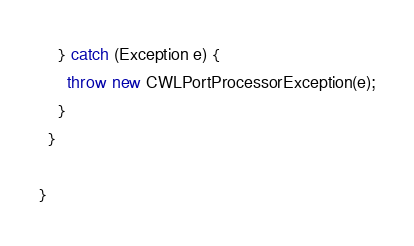<code> <loc_0><loc_0><loc_500><loc_500><_Java_>    } catch (Exception e) {
      throw new CWLPortProcessorException(e);
    }
  }
  
}
</code> 